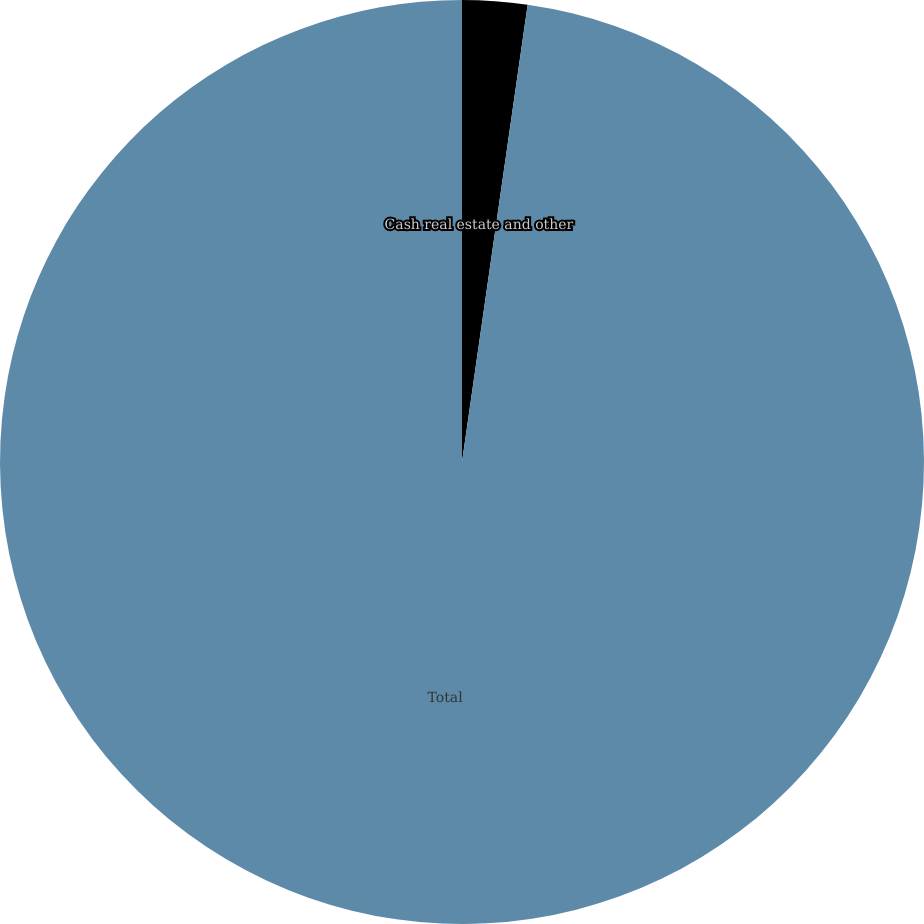<chart> <loc_0><loc_0><loc_500><loc_500><pie_chart><fcel>Cash real estate and other<fcel>Total<nl><fcel>2.27%<fcel>97.73%<nl></chart> 